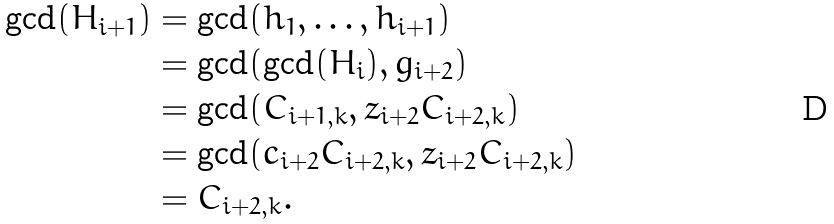Convert formula to latex. <formula><loc_0><loc_0><loc_500><loc_500>\gcd ( H _ { i + 1 } ) & = \gcd ( h _ { 1 } , \dots , h _ { i + 1 } ) \\ & = \gcd ( \gcd ( H _ { i } ) , g _ { i + 2 } ) \\ & = \gcd ( C _ { i + 1 , k } , z _ { i + 2 } C _ { i + 2 , k } ) \\ & = \gcd ( c _ { i + 2 } C _ { i + 2 , k } , z _ { i + 2 } C _ { i + 2 , k } ) \\ & = C _ { i + 2 , k } .</formula> 